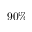<formula> <loc_0><loc_0><loc_500><loc_500>9 0 \%</formula> 